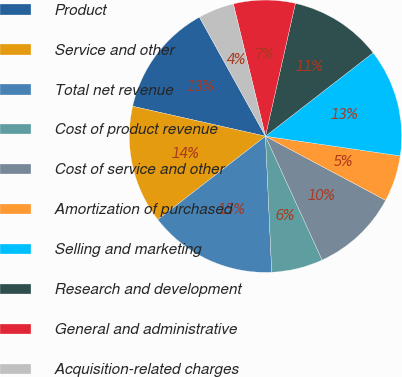<chart> <loc_0><loc_0><loc_500><loc_500><pie_chart><fcel>Product<fcel>Service and other<fcel>Total net revenue<fcel>Cost of product revenue<fcel>Cost of service and other<fcel>Amortization of purchased<fcel>Selling and marketing<fcel>Research and development<fcel>General and administrative<fcel>Acquisition-related charges<nl><fcel>13.41%<fcel>14.02%<fcel>15.24%<fcel>6.1%<fcel>10.37%<fcel>5.49%<fcel>12.8%<fcel>10.98%<fcel>7.32%<fcel>4.27%<nl></chart> 